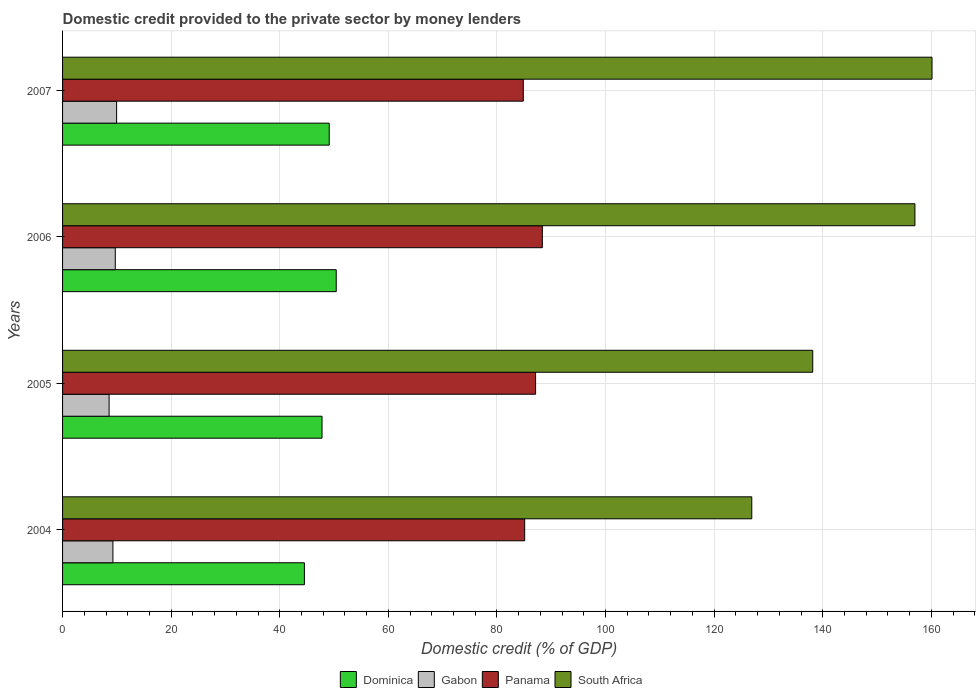How many different coloured bars are there?
Give a very brief answer. 4. How many groups of bars are there?
Your answer should be compact. 4. Are the number of bars on each tick of the Y-axis equal?
Your answer should be compact. Yes. How many bars are there on the 1st tick from the top?
Provide a succinct answer. 4. In how many cases, is the number of bars for a given year not equal to the number of legend labels?
Give a very brief answer. 0. What is the domestic credit provided to the private sector by money lenders in South Africa in 2006?
Your response must be concise. 156.98. Across all years, what is the maximum domestic credit provided to the private sector by money lenders in Panama?
Offer a terse response. 88.36. Across all years, what is the minimum domestic credit provided to the private sector by money lenders in South Africa?
Your answer should be very brief. 126.93. In which year was the domestic credit provided to the private sector by money lenders in Panama maximum?
Offer a terse response. 2006. What is the total domestic credit provided to the private sector by money lenders in South Africa in the graph?
Your answer should be very brief. 582.19. What is the difference between the domestic credit provided to the private sector by money lenders in South Africa in 2005 and that in 2007?
Make the answer very short. -21.97. What is the difference between the domestic credit provided to the private sector by money lenders in South Africa in 2004 and the domestic credit provided to the private sector by money lenders in Gabon in 2005?
Give a very brief answer. 118.36. What is the average domestic credit provided to the private sector by money lenders in South Africa per year?
Your answer should be compact. 145.55. In the year 2004, what is the difference between the domestic credit provided to the private sector by money lenders in Gabon and domestic credit provided to the private sector by money lenders in South Africa?
Your response must be concise. -117.66. What is the ratio of the domestic credit provided to the private sector by money lenders in South Africa in 2004 to that in 2006?
Make the answer very short. 0.81. Is the difference between the domestic credit provided to the private sector by money lenders in Gabon in 2006 and 2007 greater than the difference between the domestic credit provided to the private sector by money lenders in South Africa in 2006 and 2007?
Provide a succinct answer. Yes. What is the difference between the highest and the second highest domestic credit provided to the private sector by money lenders in Dominica?
Provide a short and direct response. 1.29. What is the difference between the highest and the lowest domestic credit provided to the private sector by money lenders in Panama?
Ensure brevity in your answer.  3.51. In how many years, is the domestic credit provided to the private sector by money lenders in Panama greater than the average domestic credit provided to the private sector by money lenders in Panama taken over all years?
Offer a terse response. 2. What does the 3rd bar from the top in 2005 represents?
Your answer should be very brief. Gabon. What does the 2nd bar from the bottom in 2005 represents?
Provide a short and direct response. Gabon. Is it the case that in every year, the sum of the domestic credit provided to the private sector by money lenders in Gabon and domestic credit provided to the private sector by money lenders in South Africa is greater than the domestic credit provided to the private sector by money lenders in Dominica?
Give a very brief answer. Yes. How many bars are there?
Provide a succinct answer. 16. Are all the bars in the graph horizontal?
Provide a short and direct response. Yes. What is the difference between two consecutive major ticks on the X-axis?
Keep it short and to the point. 20. Does the graph contain any zero values?
Provide a succinct answer. No. How many legend labels are there?
Your answer should be very brief. 4. What is the title of the graph?
Keep it short and to the point. Domestic credit provided to the private sector by money lenders. What is the label or title of the X-axis?
Keep it short and to the point. Domestic credit (% of GDP). What is the Domestic credit (% of GDP) in Dominica in 2004?
Give a very brief answer. 44.54. What is the Domestic credit (% of GDP) in Gabon in 2004?
Offer a terse response. 9.27. What is the Domestic credit (% of GDP) of Panama in 2004?
Give a very brief answer. 85.11. What is the Domestic credit (% of GDP) in South Africa in 2004?
Provide a succinct answer. 126.93. What is the Domestic credit (% of GDP) of Dominica in 2005?
Make the answer very short. 47.78. What is the Domestic credit (% of GDP) in Gabon in 2005?
Ensure brevity in your answer.  8.57. What is the Domestic credit (% of GDP) of Panama in 2005?
Ensure brevity in your answer.  87.12. What is the Domestic credit (% of GDP) in South Africa in 2005?
Offer a very short reply. 138.16. What is the Domestic credit (% of GDP) of Dominica in 2006?
Keep it short and to the point. 50.4. What is the Domestic credit (% of GDP) of Gabon in 2006?
Ensure brevity in your answer.  9.71. What is the Domestic credit (% of GDP) in Panama in 2006?
Offer a terse response. 88.36. What is the Domestic credit (% of GDP) of South Africa in 2006?
Provide a succinct answer. 156.98. What is the Domestic credit (% of GDP) in Dominica in 2007?
Your answer should be compact. 49.11. What is the Domestic credit (% of GDP) in Gabon in 2007?
Make the answer very short. 9.95. What is the Domestic credit (% of GDP) in Panama in 2007?
Make the answer very short. 84.85. What is the Domestic credit (% of GDP) of South Africa in 2007?
Your response must be concise. 160.12. Across all years, what is the maximum Domestic credit (% of GDP) of Dominica?
Your answer should be compact. 50.4. Across all years, what is the maximum Domestic credit (% of GDP) of Gabon?
Your answer should be very brief. 9.95. Across all years, what is the maximum Domestic credit (% of GDP) of Panama?
Offer a terse response. 88.36. Across all years, what is the maximum Domestic credit (% of GDP) of South Africa?
Provide a succinct answer. 160.12. Across all years, what is the minimum Domestic credit (% of GDP) in Dominica?
Offer a very short reply. 44.54. Across all years, what is the minimum Domestic credit (% of GDP) in Gabon?
Keep it short and to the point. 8.57. Across all years, what is the minimum Domestic credit (% of GDP) in Panama?
Keep it short and to the point. 84.85. Across all years, what is the minimum Domestic credit (% of GDP) of South Africa?
Provide a succinct answer. 126.93. What is the total Domestic credit (% of GDP) in Dominica in the graph?
Your answer should be very brief. 191.83. What is the total Domestic credit (% of GDP) of Gabon in the graph?
Keep it short and to the point. 37.5. What is the total Domestic credit (% of GDP) in Panama in the graph?
Your answer should be very brief. 345.43. What is the total Domestic credit (% of GDP) in South Africa in the graph?
Keep it short and to the point. 582.19. What is the difference between the Domestic credit (% of GDP) in Dominica in 2004 and that in 2005?
Your answer should be compact. -3.25. What is the difference between the Domestic credit (% of GDP) of Gabon in 2004 and that in 2005?
Make the answer very short. 0.7. What is the difference between the Domestic credit (% of GDP) of Panama in 2004 and that in 2005?
Provide a succinct answer. -2.01. What is the difference between the Domestic credit (% of GDP) in South Africa in 2004 and that in 2005?
Make the answer very short. -11.23. What is the difference between the Domestic credit (% of GDP) of Dominica in 2004 and that in 2006?
Provide a short and direct response. -5.86. What is the difference between the Domestic credit (% of GDP) in Gabon in 2004 and that in 2006?
Keep it short and to the point. -0.44. What is the difference between the Domestic credit (% of GDP) of Panama in 2004 and that in 2006?
Your answer should be compact. -3.25. What is the difference between the Domestic credit (% of GDP) of South Africa in 2004 and that in 2006?
Offer a terse response. -30.04. What is the difference between the Domestic credit (% of GDP) in Dominica in 2004 and that in 2007?
Your answer should be compact. -4.57. What is the difference between the Domestic credit (% of GDP) of Gabon in 2004 and that in 2007?
Provide a short and direct response. -0.68. What is the difference between the Domestic credit (% of GDP) in Panama in 2004 and that in 2007?
Your response must be concise. 0.25. What is the difference between the Domestic credit (% of GDP) in South Africa in 2004 and that in 2007?
Make the answer very short. -33.19. What is the difference between the Domestic credit (% of GDP) in Dominica in 2005 and that in 2006?
Your response must be concise. -2.62. What is the difference between the Domestic credit (% of GDP) in Gabon in 2005 and that in 2006?
Your answer should be very brief. -1.14. What is the difference between the Domestic credit (% of GDP) in Panama in 2005 and that in 2006?
Offer a very short reply. -1.24. What is the difference between the Domestic credit (% of GDP) of South Africa in 2005 and that in 2006?
Offer a very short reply. -18.82. What is the difference between the Domestic credit (% of GDP) in Dominica in 2005 and that in 2007?
Make the answer very short. -1.32. What is the difference between the Domestic credit (% of GDP) of Gabon in 2005 and that in 2007?
Your answer should be very brief. -1.38. What is the difference between the Domestic credit (% of GDP) in Panama in 2005 and that in 2007?
Keep it short and to the point. 2.26. What is the difference between the Domestic credit (% of GDP) of South Africa in 2005 and that in 2007?
Keep it short and to the point. -21.97. What is the difference between the Domestic credit (% of GDP) of Dominica in 2006 and that in 2007?
Provide a succinct answer. 1.29. What is the difference between the Domestic credit (% of GDP) in Gabon in 2006 and that in 2007?
Your answer should be very brief. -0.24. What is the difference between the Domestic credit (% of GDP) of Panama in 2006 and that in 2007?
Your answer should be compact. 3.51. What is the difference between the Domestic credit (% of GDP) of South Africa in 2006 and that in 2007?
Your answer should be very brief. -3.15. What is the difference between the Domestic credit (% of GDP) in Dominica in 2004 and the Domestic credit (% of GDP) in Gabon in 2005?
Your answer should be very brief. 35.97. What is the difference between the Domestic credit (% of GDP) in Dominica in 2004 and the Domestic credit (% of GDP) in Panama in 2005?
Offer a terse response. -42.58. What is the difference between the Domestic credit (% of GDP) in Dominica in 2004 and the Domestic credit (% of GDP) in South Africa in 2005?
Ensure brevity in your answer.  -93.62. What is the difference between the Domestic credit (% of GDP) in Gabon in 2004 and the Domestic credit (% of GDP) in Panama in 2005?
Your answer should be compact. -77.85. What is the difference between the Domestic credit (% of GDP) of Gabon in 2004 and the Domestic credit (% of GDP) of South Africa in 2005?
Your response must be concise. -128.89. What is the difference between the Domestic credit (% of GDP) in Panama in 2004 and the Domestic credit (% of GDP) in South Africa in 2005?
Ensure brevity in your answer.  -53.05. What is the difference between the Domestic credit (% of GDP) of Dominica in 2004 and the Domestic credit (% of GDP) of Gabon in 2006?
Ensure brevity in your answer.  34.83. What is the difference between the Domestic credit (% of GDP) of Dominica in 2004 and the Domestic credit (% of GDP) of Panama in 2006?
Ensure brevity in your answer.  -43.82. What is the difference between the Domestic credit (% of GDP) of Dominica in 2004 and the Domestic credit (% of GDP) of South Africa in 2006?
Your answer should be compact. -112.44. What is the difference between the Domestic credit (% of GDP) of Gabon in 2004 and the Domestic credit (% of GDP) of Panama in 2006?
Provide a succinct answer. -79.09. What is the difference between the Domestic credit (% of GDP) in Gabon in 2004 and the Domestic credit (% of GDP) in South Africa in 2006?
Offer a very short reply. -147.71. What is the difference between the Domestic credit (% of GDP) in Panama in 2004 and the Domestic credit (% of GDP) in South Africa in 2006?
Ensure brevity in your answer.  -71.87. What is the difference between the Domestic credit (% of GDP) of Dominica in 2004 and the Domestic credit (% of GDP) of Gabon in 2007?
Your response must be concise. 34.58. What is the difference between the Domestic credit (% of GDP) of Dominica in 2004 and the Domestic credit (% of GDP) of Panama in 2007?
Give a very brief answer. -40.32. What is the difference between the Domestic credit (% of GDP) of Dominica in 2004 and the Domestic credit (% of GDP) of South Africa in 2007?
Your answer should be compact. -115.59. What is the difference between the Domestic credit (% of GDP) in Gabon in 2004 and the Domestic credit (% of GDP) in Panama in 2007?
Provide a short and direct response. -75.58. What is the difference between the Domestic credit (% of GDP) in Gabon in 2004 and the Domestic credit (% of GDP) in South Africa in 2007?
Make the answer very short. -150.85. What is the difference between the Domestic credit (% of GDP) in Panama in 2004 and the Domestic credit (% of GDP) in South Africa in 2007?
Your answer should be compact. -75.02. What is the difference between the Domestic credit (% of GDP) of Dominica in 2005 and the Domestic credit (% of GDP) of Gabon in 2006?
Give a very brief answer. 38.08. What is the difference between the Domestic credit (% of GDP) of Dominica in 2005 and the Domestic credit (% of GDP) of Panama in 2006?
Your answer should be compact. -40.57. What is the difference between the Domestic credit (% of GDP) in Dominica in 2005 and the Domestic credit (% of GDP) in South Africa in 2006?
Your answer should be compact. -109.19. What is the difference between the Domestic credit (% of GDP) in Gabon in 2005 and the Domestic credit (% of GDP) in Panama in 2006?
Your response must be concise. -79.79. What is the difference between the Domestic credit (% of GDP) in Gabon in 2005 and the Domestic credit (% of GDP) in South Africa in 2006?
Keep it short and to the point. -148.41. What is the difference between the Domestic credit (% of GDP) in Panama in 2005 and the Domestic credit (% of GDP) in South Africa in 2006?
Your answer should be very brief. -69.86. What is the difference between the Domestic credit (% of GDP) in Dominica in 2005 and the Domestic credit (% of GDP) in Gabon in 2007?
Give a very brief answer. 37.83. What is the difference between the Domestic credit (% of GDP) in Dominica in 2005 and the Domestic credit (% of GDP) in Panama in 2007?
Your response must be concise. -37.07. What is the difference between the Domestic credit (% of GDP) of Dominica in 2005 and the Domestic credit (% of GDP) of South Africa in 2007?
Provide a succinct answer. -112.34. What is the difference between the Domestic credit (% of GDP) in Gabon in 2005 and the Domestic credit (% of GDP) in Panama in 2007?
Keep it short and to the point. -76.28. What is the difference between the Domestic credit (% of GDP) of Gabon in 2005 and the Domestic credit (% of GDP) of South Africa in 2007?
Make the answer very short. -151.55. What is the difference between the Domestic credit (% of GDP) of Panama in 2005 and the Domestic credit (% of GDP) of South Africa in 2007?
Provide a short and direct response. -73.01. What is the difference between the Domestic credit (% of GDP) in Dominica in 2006 and the Domestic credit (% of GDP) in Gabon in 2007?
Ensure brevity in your answer.  40.45. What is the difference between the Domestic credit (% of GDP) of Dominica in 2006 and the Domestic credit (% of GDP) of Panama in 2007?
Your answer should be very brief. -34.45. What is the difference between the Domestic credit (% of GDP) in Dominica in 2006 and the Domestic credit (% of GDP) in South Africa in 2007?
Your response must be concise. -109.73. What is the difference between the Domestic credit (% of GDP) in Gabon in 2006 and the Domestic credit (% of GDP) in Panama in 2007?
Provide a succinct answer. -75.14. What is the difference between the Domestic credit (% of GDP) of Gabon in 2006 and the Domestic credit (% of GDP) of South Africa in 2007?
Your answer should be compact. -150.42. What is the difference between the Domestic credit (% of GDP) of Panama in 2006 and the Domestic credit (% of GDP) of South Africa in 2007?
Ensure brevity in your answer.  -71.77. What is the average Domestic credit (% of GDP) of Dominica per year?
Offer a terse response. 47.96. What is the average Domestic credit (% of GDP) of Gabon per year?
Your answer should be compact. 9.38. What is the average Domestic credit (% of GDP) in Panama per year?
Ensure brevity in your answer.  86.36. What is the average Domestic credit (% of GDP) in South Africa per year?
Offer a very short reply. 145.55. In the year 2004, what is the difference between the Domestic credit (% of GDP) of Dominica and Domestic credit (% of GDP) of Gabon?
Keep it short and to the point. 35.27. In the year 2004, what is the difference between the Domestic credit (% of GDP) of Dominica and Domestic credit (% of GDP) of Panama?
Your response must be concise. -40.57. In the year 2004, what is the difference between the Domestic credit (% of GDP) in Dominica and Domestic credit (% of GDP) in South Africa?
Give a very brief answer. -82.4. In the year 2004, what is the difference between the Domestic credit (% of GDP) in Gabon and Domestic credit (% of GDP) in Panama?
Keep it short and to the point. -75.83. In the year 2004, what is the difference between the Domestic credit (% of GDP) in Gabon and Domestic credit (% of GDP) in South Africa?
Offer a terse response. -117.66. In the year 2004, what is the difference between the Domestic credit (% of GDP) of Panama and Domestic credit (% of GDP) of South Africa?
Offer a very short reply. -41.83. In the year 2005, what is the difference between the Domestic credit (% of GDP) of Dominica and Domestic credit (% of GDP) of Gabon?
Offer a terse response. 39.21. In the year 2005, what is the difference between the Domestic credit (% of GDP) of Dominica and Domestic credit (% of GDP) of Panama?
Your answer should be compact. -39.33. In the year 2005, what is the difference between the Domestic credit (% of GDP) of Dominica and Domestic credit (% of GDP) of South Africa?
Your answer should be compact. -90.38. In the year 2005, what is the difference between the Domestic credit (% of GDP) of Gabon and Domestic credit (% of GDP) of Panama?
Offer a very short reply. -78.55. In the year 2005, what is the difference between the Domestic credit (% of GDP) of Gabon and Domestic credit (% of GDP) of South Africa?
Offer a very short reply. -129.59. In the year 2005, what is the difference between the Domestic credit (% of GDP) in Panama and Domestic credit (% of GDP) in South Africa?
Keep it short and to the point. -51.04. In the year 2006, what is the difference between the Domestic credit (% of GDP) of Dominica and Domestic credit (% of GDP) of Gabon?
Keep it short and to the point. 40.69. In the year 2006, what is the difference between the Domestic credit (% of GDP) of Dominica and Domestic credit (% of GDP) of Panama?
Provide a succinct answer. -37.96. In the year 2006, what is the difference between the Domestic credit (% of GDP) in Dominica and Domestic credit (% of GDP) in South Africa?
Ensure brevity in your answer.  -106.58. In the year 2006, what is the difference between the Domestic credit (% of GDP) of Gabon and Domestic credit (% of GDP) of Panama?
Provide a succinct answer. -78.65. In the year 2006, what is the difference between the Domestic credit (% of GDP) of Gabon and Domestic credit (% of GDP) of South Africa?
Ensure brevity in your answer.  -147.27. In the year 2006, what is the difference between the Domestic credit (% of GDP) in Panama and Domestic credit (% of GDP) in South Africa?
Ensure brevity in your answer.  -68.62. In the year 2007, what is the difference between the Domestic credit (% of GDP) of Dominica and Domestic credit (% of GDP) of Gabon?
Your answer should be compact. 39.16. In the year 2007, what is the difference between the Domestic credit (% of GDP) of Dominica and Domestic credit (% of GDP) of Panama?
Offer a terse response. -35.74. In the year 2007, what is the difference between the Domestic credit (% of GDP) in Dominica and Domestic credit (% of GDP) in South Africa?
Give a very brief answer. -111.02. In the year 2007, what is the difference between the Domestic credit (% of GDP) in Gabon and Domestic credit (% of GDP) in Panama?
Ensure brevity in your answer.  -74.9. In the year 2007, what is the difference between the Domestic credit (% of GDP) in Gabon and Domestic credit (% of GDP) in South Africa?
Give a very brief answer. -150.17. In the year 2007, what is the difference between the Domestic credit (% of GDP) in Panama and Domestic credit (% of GDP) in South Africa?
Keep it short and to the point. -75.27. What is the ratio of the Domestic credit (% of GDP) of Dominica in 2004 to that in 2005?
Your answer should be compact. 0.93. What is the ratio of the Domestic credit (% of GDP) of Gabon in 2004 to that in 2005?
Your answer should be compact. 1.08. What is the ratio of the Domestic credit (% of GDP) of Panama in 2004 to that in 2005?
Make the answer very short. 0.98. What is the ratio of the Domestic credit (% of GDP) in South Africa in 2004 to that in 2005?
Make the answer very short. 0.92. What is the ratio of the Domestic credit (% of GDP) in Dominica in 2004 to that in 2006?
Give a very brief answer. 0.88. What is the ratio of the Domestic credit (% of GDP) of Gabon in 2004 to that in 2006?
Provide a succinct answer. 0.95. What is the ratio of the Domestic credit (% of GDP) in Panama in 2004 to that in 2006?
Make the answer very short. 0.96. What is the ratio of the Domestic credit (% of GDP) of South Africa in 2004 to that in 2006?
Offer a terse response. 0.81. What is the ratio of the Domestic credit (% of GDP) of Dominica in 2004 to that in 2007?
Make the answer very short. 0.91. What is the ratio of the Domestic credit (% of GDP) of Gabon in 2004 to that in 2007?
Keep it short and to the point. 0.93. What is the ratio of the Domestic credit (% of GDP) in South Africa in 2004 to that in 2007?
Offer a very short reply. 0.79. What is the ratio of the Domestic credit (% of GDP) of Dominica in 2005 to that in 2006?
Offer a terse response. 0.95. What is the ratio of the Domestic credit (% of GDP) of Gabon in 2005 to that in 2006?
Your answer should be very brief. 0.88. What is the ratio of the Domestic credit (% of GDP) in Panama in 2005 to that in 2006?
Your answer should be very brief. 0.99. What is the ratio of the Domestic credit (% of GDP) in South Africa in 2005 to that in 2006?
Give a very brief answer. 0.88. What is the ratio of the Domestic credit (% of GDP) of Gabon in 2005 to that in 2007?
Make the answer very short. 0.86. What is the ratio of the Domestic credit (% of GDP) in Panama in 2005 to that in 2007?
Give a very brief answer. 1.03. What is the ratio of the Domestic credit (% of GDP) in South Africa in 2005 to that in 2007?
Your answer should be compact. 0.86. What is the ratio of the Domestic credit (% of GDP) in Dominica in 2006 to that in 2007?
Keep it short and to the point. 1.03. What is the ratio of the Domestic credit (% of GDP) in Gabon in 2006 to that in 2007?
Make the answer very short. 0.98. What is the ratio of the Domestic credit (% of GDP) of Panama in 2006 to that in 2007?
Your response must be concise. 1.04. What is the ratio of the Domestic credit (% of GDP) in South Africa in 2006 to that in 2007?
Make the answer very short. 0.98. What is the difference between the highest and the second highest Domestic credit (% of GDP) in Dominica?
Your answer should be very brief. 1.29. What is the difference between the highest and the second highest Domestic credit (% of GDP) of Gabon?
Provide a succinct answer. 0.24. What is the difference between the highest and the second highest Domestic credit (% of GDP) of Panama?
Provide a short and direct response. 1.24. What is the difference between the highest and the second highest Domestic credit (% of GDP) in South Africa?
Your answer should be compact. 3.15. What is the difference between the highest and the lowest Domestic credit (% of GDP) of Dominica?
Provide a short and direct response. 5.86. What is the difference between the highest and the lowest Domestic credit (% of GDP) of Gabon?
Provide a short and direct response. 1.38. What is the difference between the highest and the lowest Domestic credit (% of GDP) in Panama?
Your answer should be compact. 3.51. What is the difference between the highest and the lowest Domestic credit (% of GDP) in South Africa?
Give a very brief answer. 33.19. 